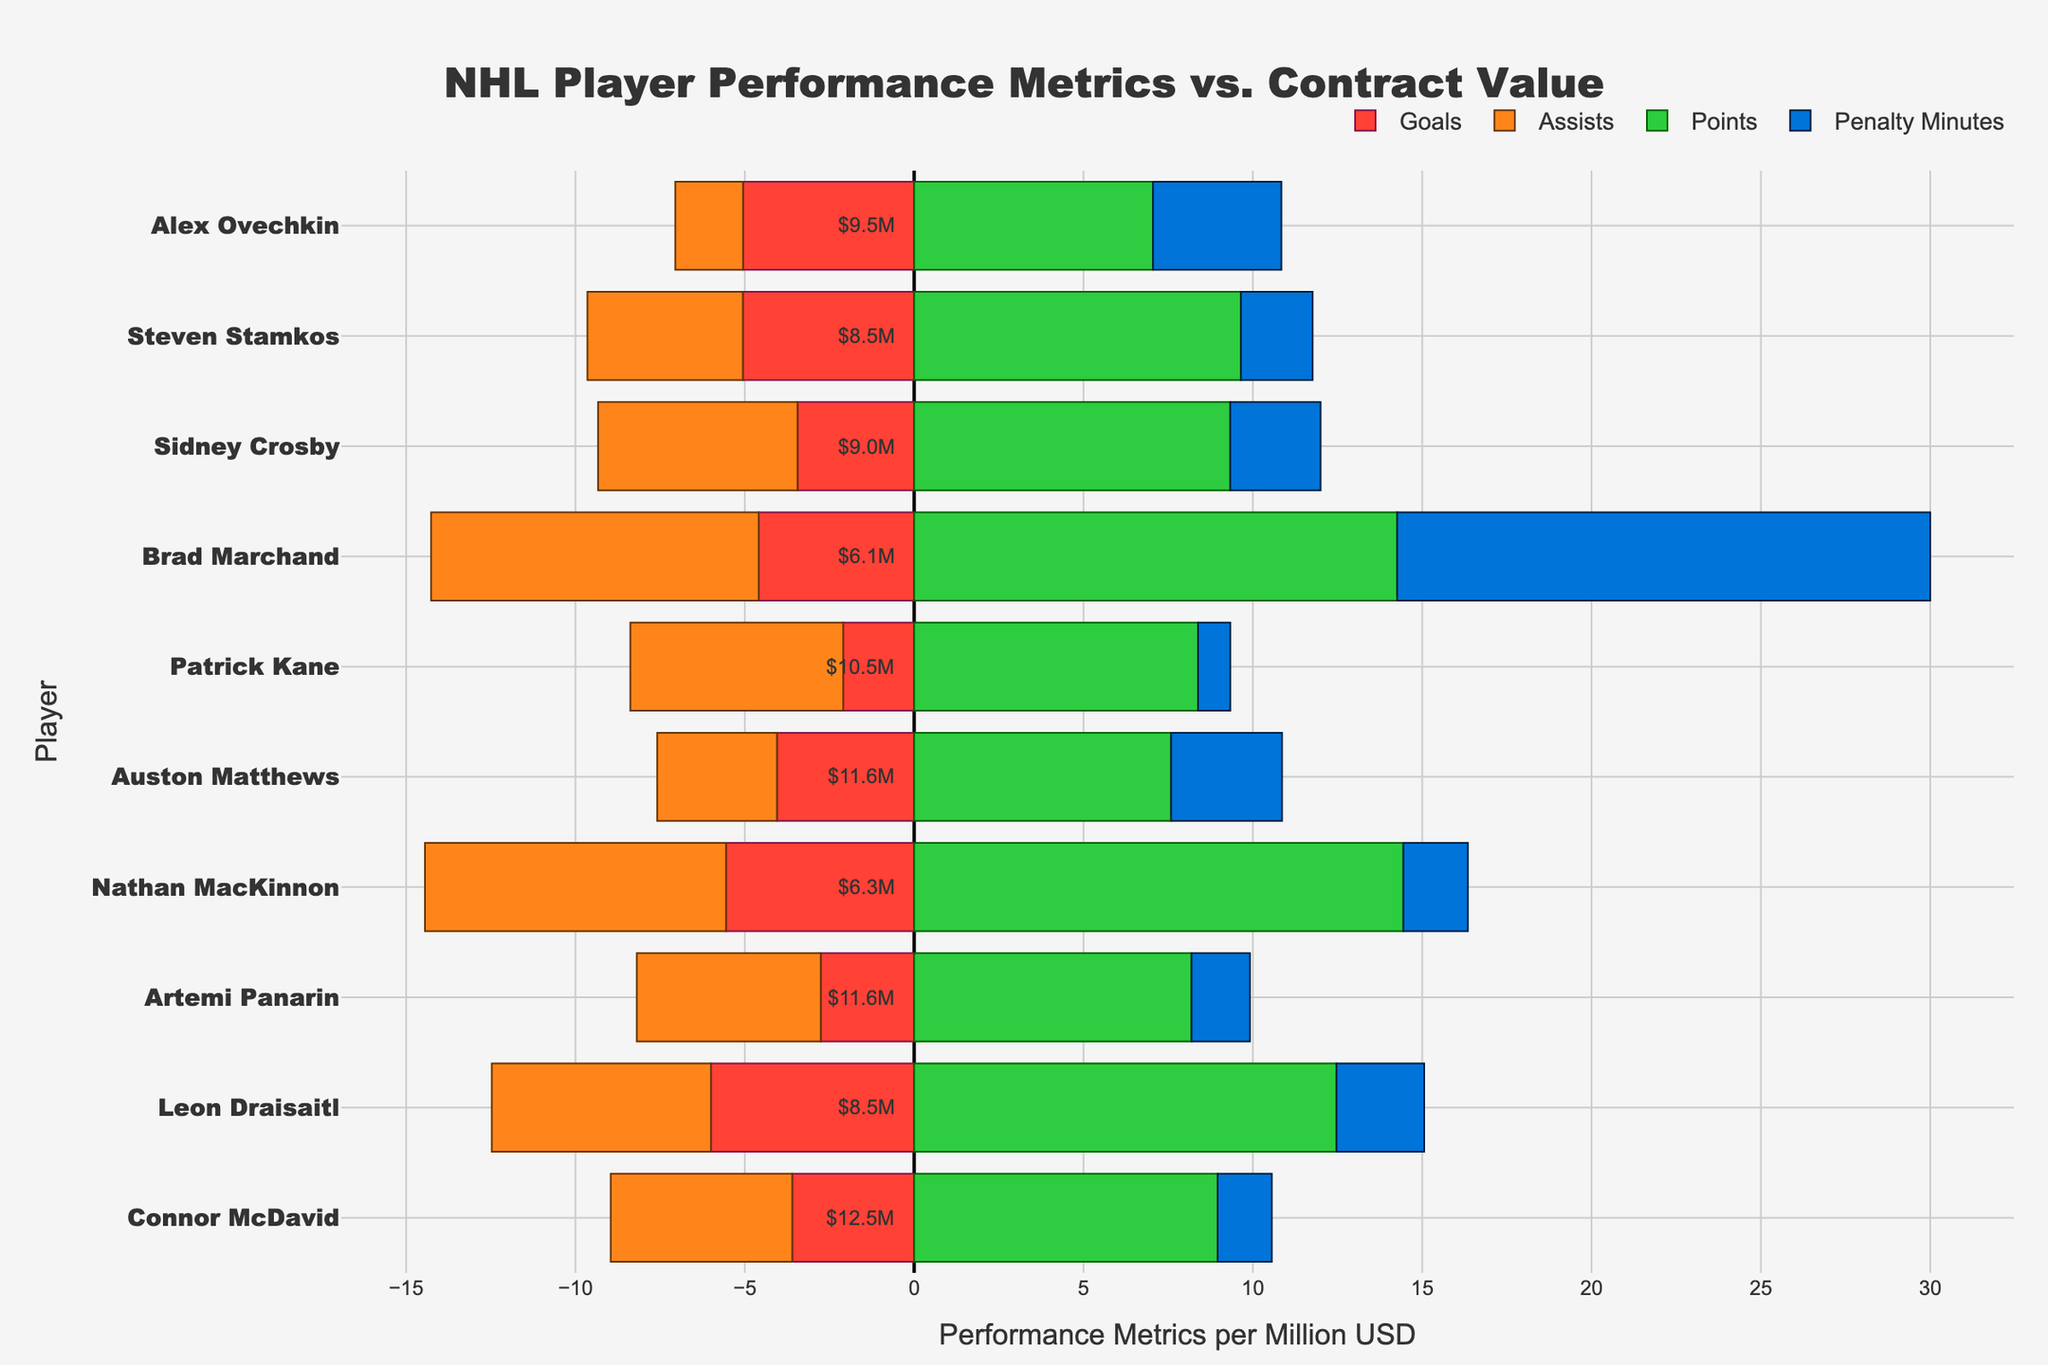what's the player with the highest points normalized by contract value? Look at the 'Points' section of the bar chart and identify the player with the longest green bar.
Answer: Nathan MacKinnon Which player has the highest penalty minutes normalized by contract value? Look at the 'Penalty Minutes' section of the bar chart and identify the player with the longest blue bar.
Answer: Brad Marchand Is there any player whose normalized assists are greater than their normalized goals? Compare the length of the orange bars (Assists) with the length of the red bars (Goals) for each player.
Answer: Yes Which two players have the closest normalized points values? Examine the green bars for the 'Points' section and compare their lengths to identify the two players with the closest values.
Answer: Patrick Kane and Auston Matthews For which player does the combination of normalized goals and normalized assists approximately equal their normalized points? Add the lengths of the red (Goals) and orange (Assists) bars for each player and compare it to the length of the green bar (Points).
Answer: Leon Draisaitl Which player has the least normalized goals? Identify the player with the shortest red bar in the 'Goals' section.
Answer: Patrick Kane Does any player have zero penalty minutes normalized by contract value? Check if there are any players without a blue bar in the 'Penalty Minutes' section.
Answer: No What's the player with the second highest normalized assists? Look at the 'Assists' section of the bar chart and identify the player with the second longest orange bar.
Answer: Artemi Panarin How many players have more than 10 normalized penalty minutes? Count the number of players with relatively long blue bars in the 'Penalty Minutes' section.
Answer: Three players Which player has the closest values between normalized goals and assists? Compare the lengths of the red (Goals) and orange (Assists) bars for each player and identify the player with the smallest difference.
Answer: Steven Stamkos 